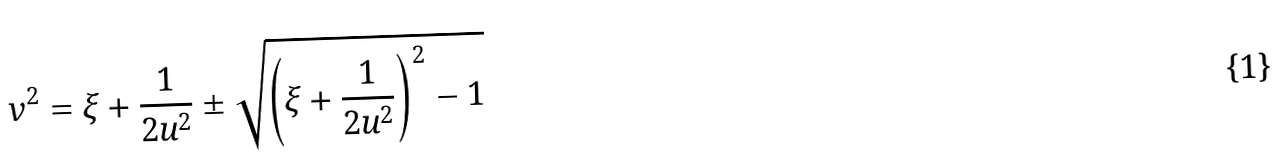Convert formula to latex. <formula><loc_0><loc_0><loc_500><loc_500>v ^ { 2 } = \xi + \frac { 1 } { 2 u ^ { 2 } } \pm \sqrt { \left ( \xi + \frac { 1 } { 2 u ^ { 2 } } \right ) ^ { 2 } - 1 }</formula> 